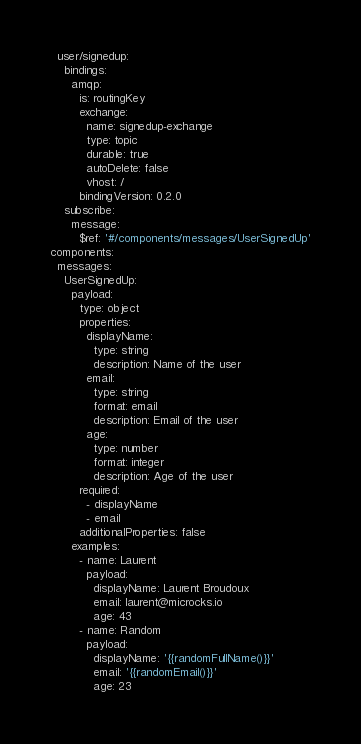<code> <loc_0><loc_0><loc_500><loc_500><_YAML_>  user/signedup:
    bindings:
      amqp:
        is: routingKey
        exchange:
          name: signedup-exchange
          type: topic
          durable: true
          autoDelete: false
          vhost: /
        bindingVersion: 0.2.0
    subscribe:
      message:
        $ref: '#/components/messages/UserSignedUp'
components:
  messages:
    UserSignedUp:
      payload:
        type: object
        properties:
          displayName:
            type: string
            description: Name of the user
          email:
            type: string
            format: email
            description: Email of the user
          age:
            type: number
            format: integer
            description: Age of the user
        required:
          - displayName
          - email
        additionalProperties: false
      examples:
        - name: Laurent
          payload:
            displayName: Laurent Broudoux
            email: laurent@microcks.io
            age: 43
        - name: Random
          payload:
            displayName: '{{randomFullName()}}'
            email: '{{randomEmail()}}'
            age: 23</code> 